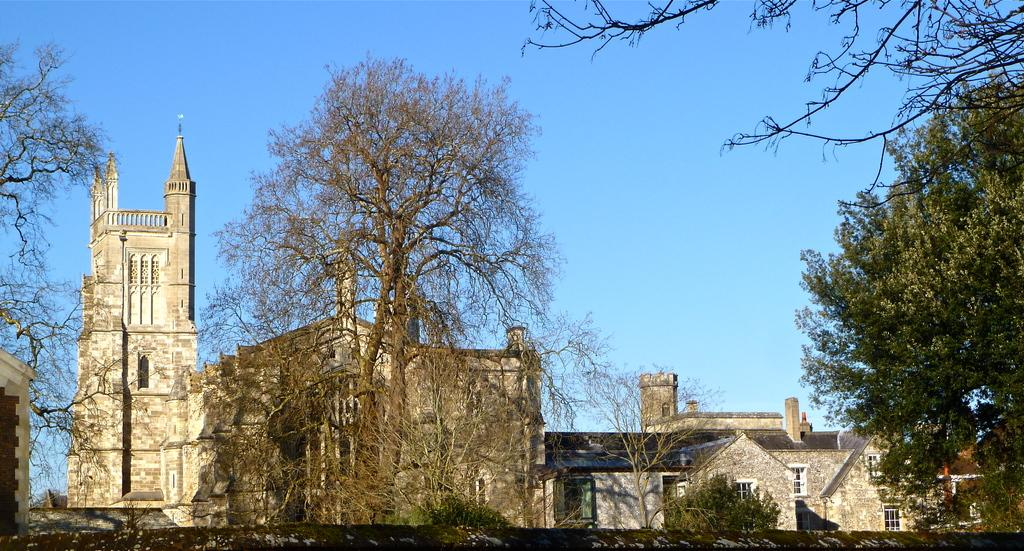What type of structures can be seen in the image? There are houses in the image. What other natural elements are present in the image? There are trees in the image. What can be seen in the distance in the image? The sky is visible in the background of the image. What type of polish is being applied to the event in the image? There is no mention of polish or an event in the image; it features houses and trees with a visible sky in the background. 